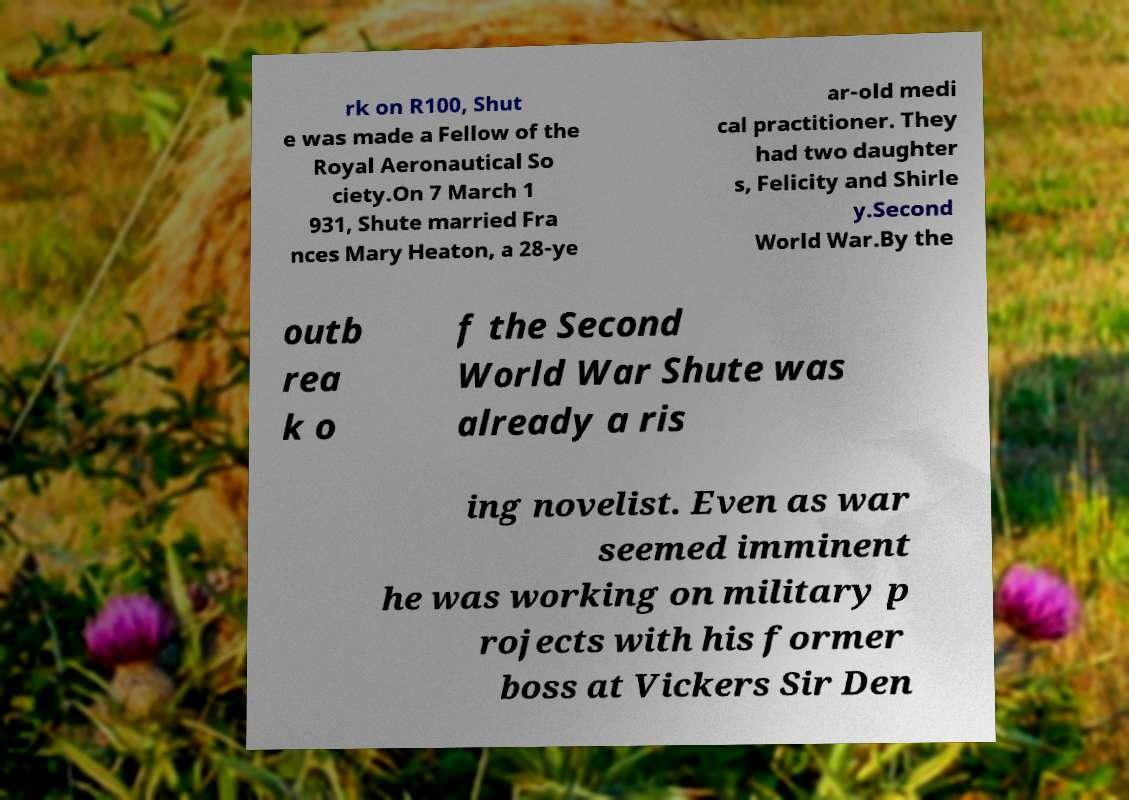What messages or text are displayed in this image? I need them in a readable, typed format. rk on R100, Shut e was made a Fellow of the Royal Aeronautical So ciety.On 7 March 1 931, Shute married Fra nces Mary Heaton, a 28-ye ar-old medi cal practitioner. They had two daughter s, Felicity and Shirle y.Second World War.By the outb rea k o f the Second World War Shute was already a ris ing novelist. Even as war seemed imminent he was working on military p rojects with his former boss at Vickers Sir Den 